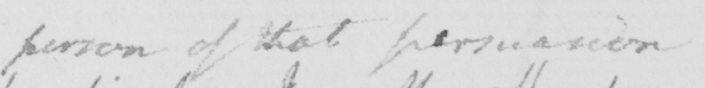Can you read and transcribe this handwriting? person of that persuasion 